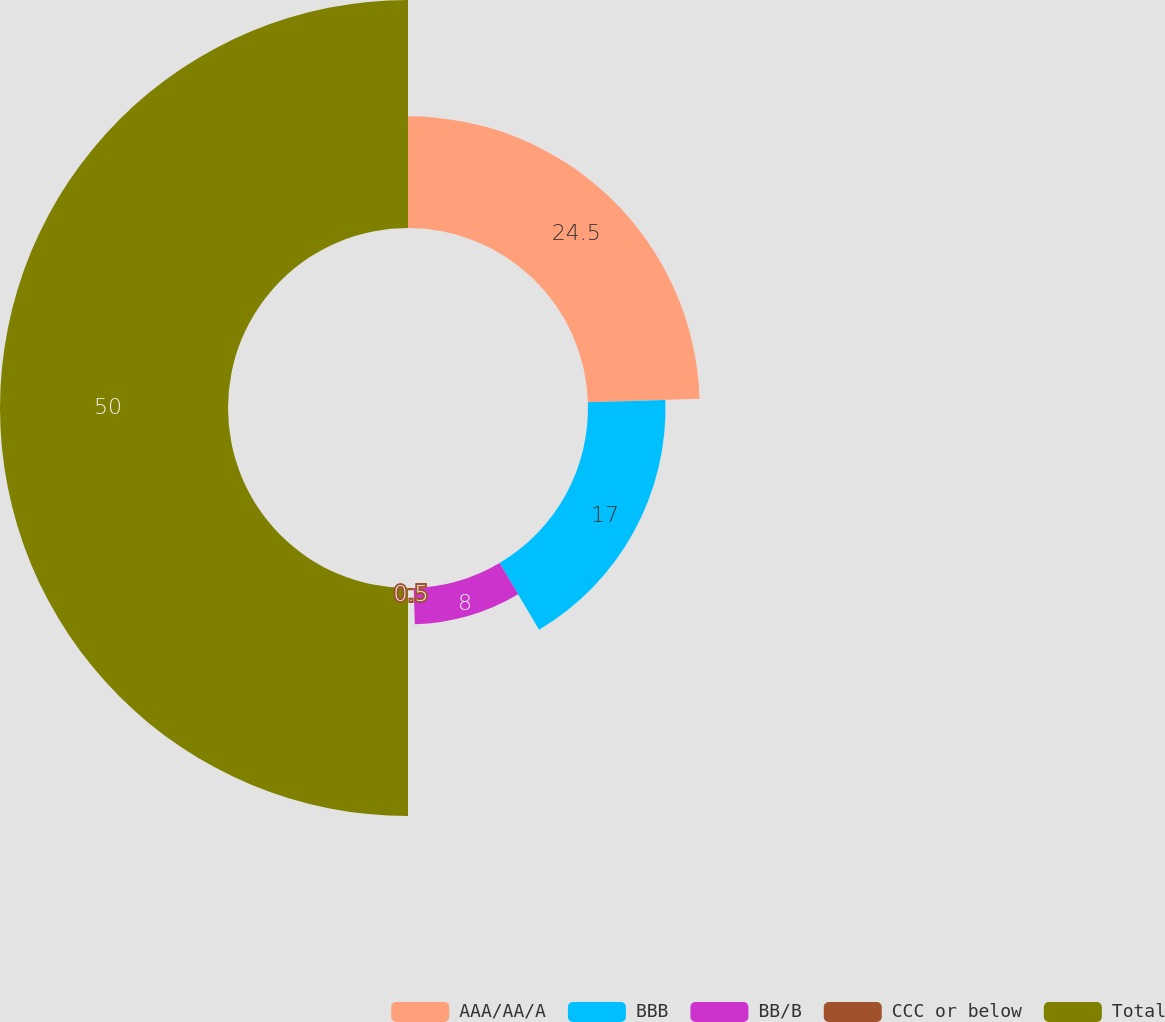Convert chart to OTSL. <chart><loc_0><loc_0><loc_500><loc_500><pie_chart><fcel>AAA/AA/A<fcel>BBB<fcel>BB/B<fcel>CCC or below<fcel>Total<nl><fcel>24.5%<fcel>17.0%<fcel>8.0%<fcel>0.5%<fcel>50.0%<nl></chart> 